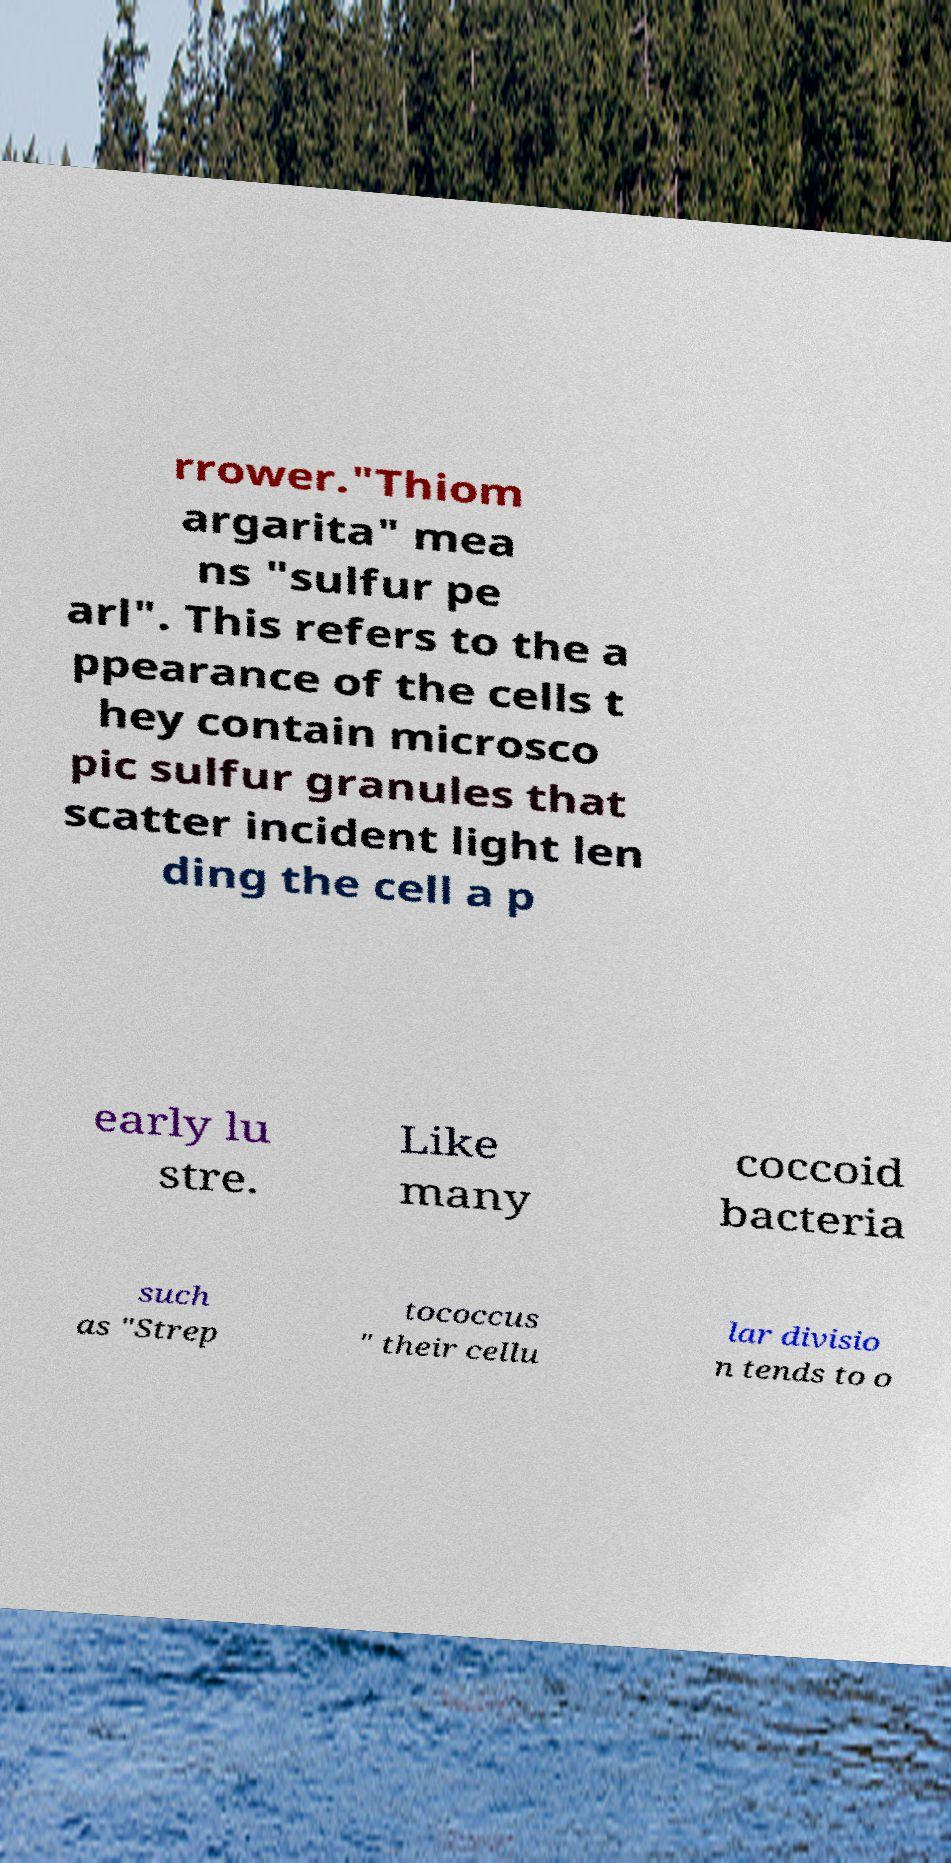Please identify and transcribe the text found in this image. rrower."Thiom argarita" mea ns "sulfur pe arl". This refers to the a ppearance of the cells t hey contain microsco pic sulfur granules that scatter incident light len ding the cell a p early lu stre. Like many coccoid bacteria such as "Strep tococcus " their cellu lar divisio n tends to o 